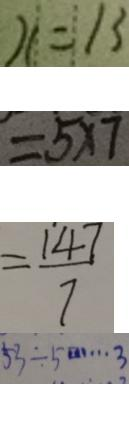Convert formula to latex. <formula><loc_0><loc_0><loc_500><loc_500>x = 1 3 
 = 5 \times 7 
 = \frac { 1 4 7 } { 7 } 
 5 3 \div 5 \cdots 3</formula> 